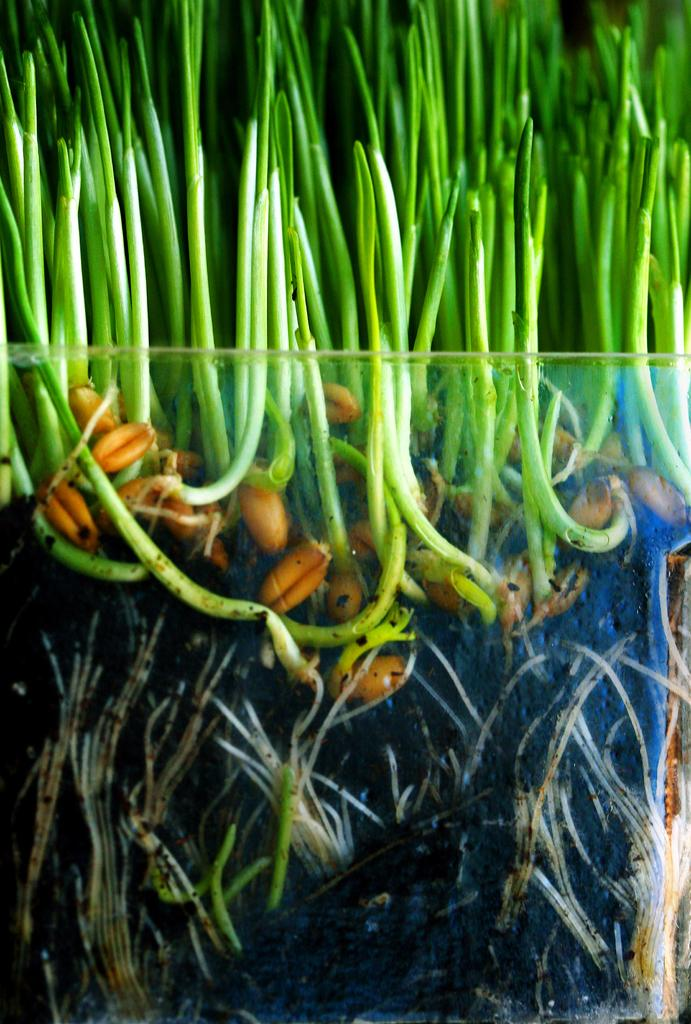What type of plant life is visible in the image? There are sprouts in the image. How are the sprouts contained in the image? The sprouts are in a glass tray. What type of trousers are being worn by the sprouts in the image? There are no trousers present in the image, as the subject is sprouts, which are plants and not capable of wearing clothing. 